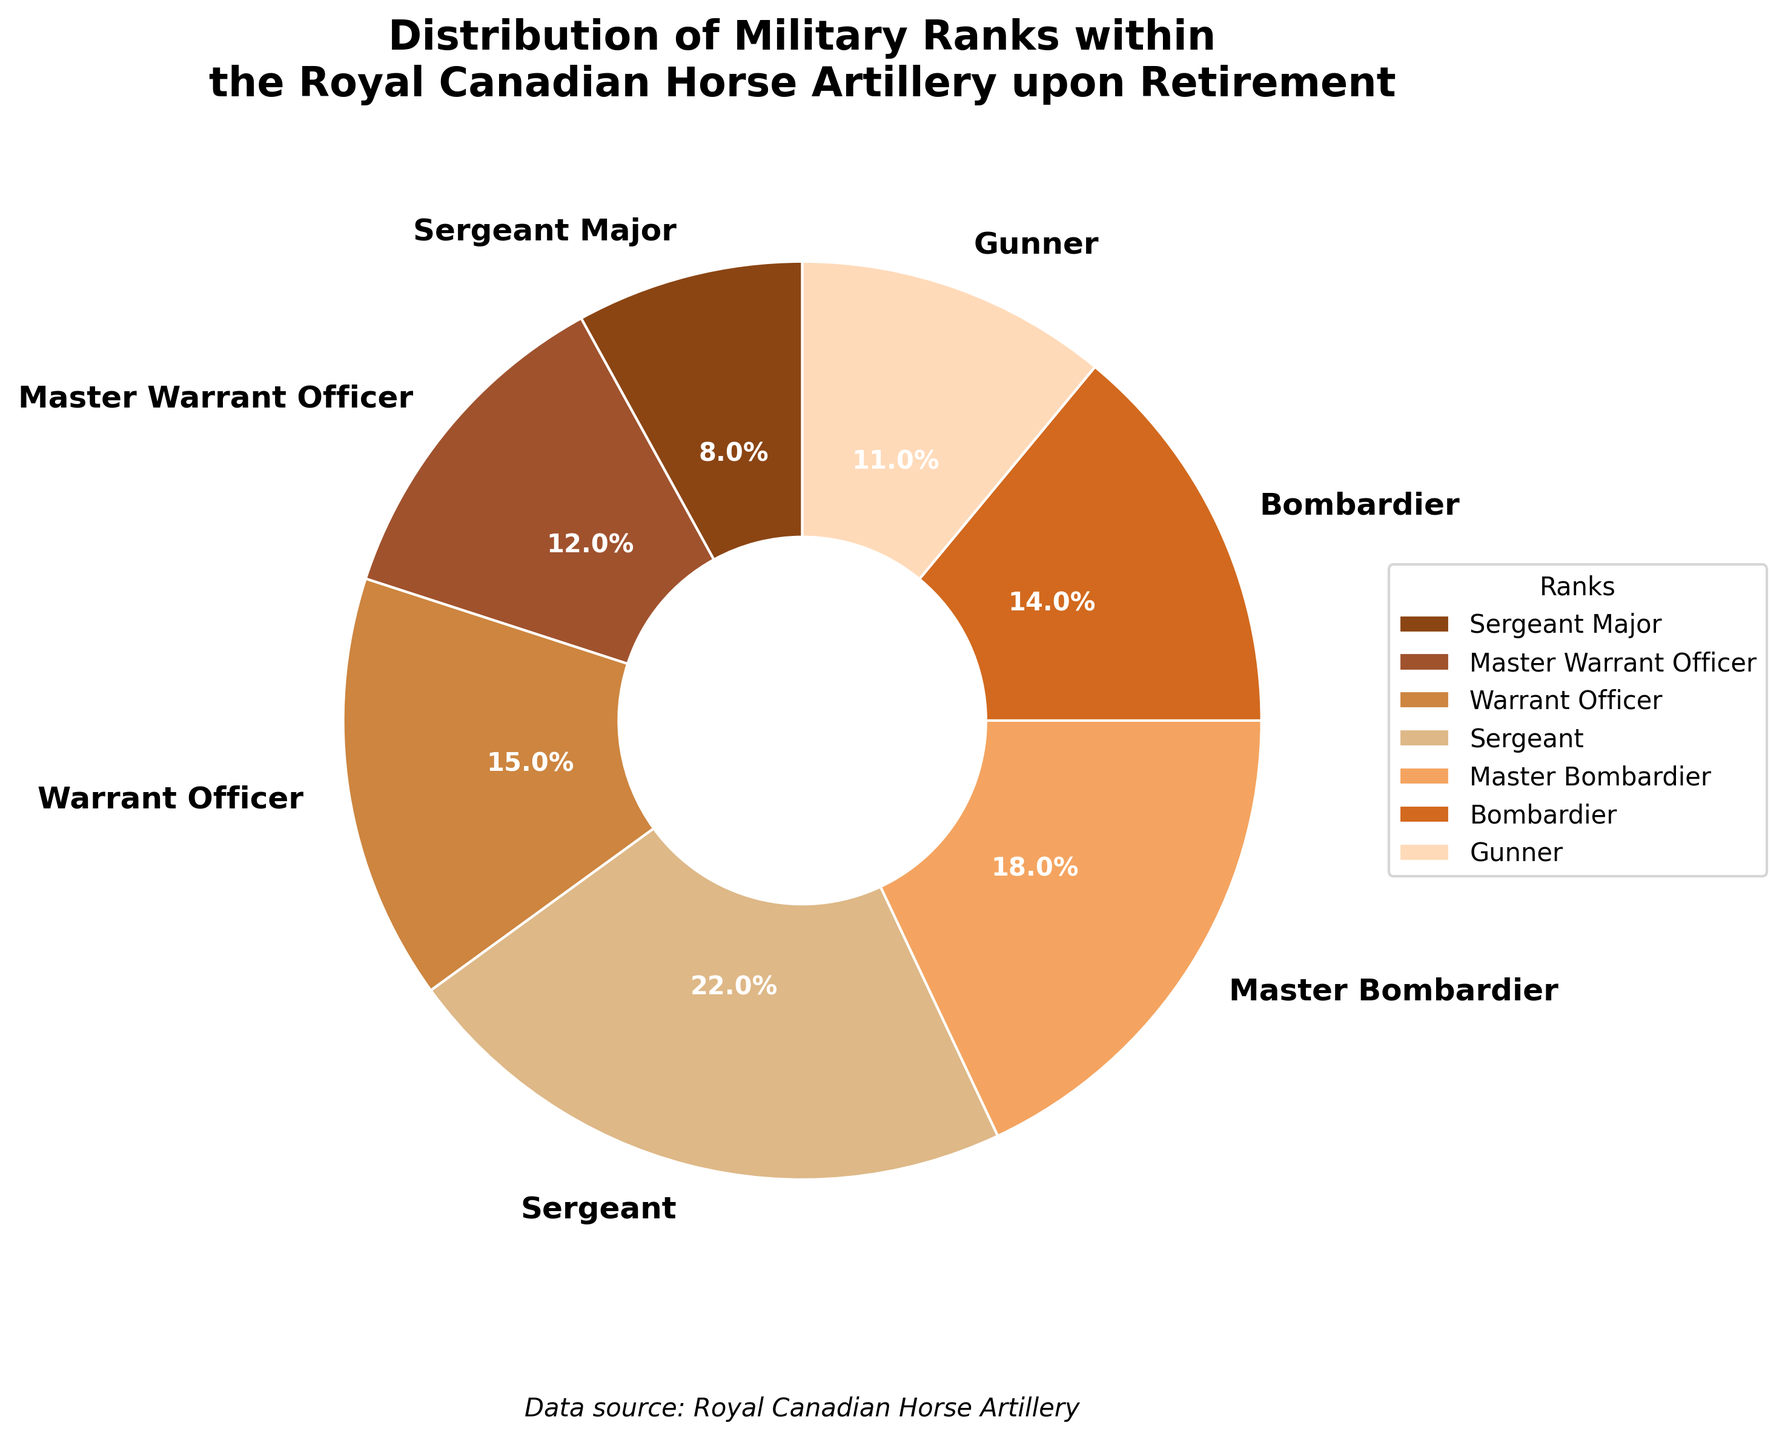Who holds the smallest percentage among the ranks? The percentage values for each rank are displayed on the pie chart. The rank with the smallest percentage is Sergeant Major with 8%.
Answer: Sergeant Major What is the combined percentage of the Bombardier and Master Bombardier ranks? According to the pie chart, Bombardier is 14% and Master Bombardier is 18%. Adding these two percentages together yields 14% + 18% = 32%.
Answer: 32% Which rank has a larger percentage, Warrant Officer or Sergeant Major? The pie chart shows that Warrant Officer has 15% and Sergeant Major has 8%. Since 15% is larger than 8%, Warrant Officer has a larger percentage.
Answer: Warrant Officer What is the median value of the percentages across all ranks? First, list the percentages in ascending order: 8%, 11%, 12%, 14%, 15%, 18%, 22%. Since there are seven values, the median is the fourth value in this ordered list: 14%.
Answer: 14% Are there more Gunners or Sergeants upon retirement? The pie chart shows that Gunners make up 11% and Sergeants make up 22%. Since 22% is greater than 11%, there are more Sergeants.
Answer: Sergeants How much greater is the percentage of Sergeants compared to Gunners? The percentage of Sergeants is 22% and the percentage of Gunners is 11%. The difference between them is 22% - 11% = 11%.
Answer: 11% Which ranks combine to make up exactly half of the total retirees (50%)? By examining the pie chart, we need to find a combination that equals 50%. The values of 22% (Sergeant) and 18% (Master Bombardier) give 40%, and adding 11% (Gunner) gives a total of 51%. So, Bombardier (14%) and Master Bombardier (18%) combine to 32%. Adding any lower percentage won't work. Therefore, nearly half.
Answer: Bombardier and Master Bombardier + any other rank What colors represent the Sergeant Major and Gunner ranks? Refer to the chart's colors to identify the ranks. Sergeant Major is represented by a light brown color, and Gunner is represented by a peach color.
Answer: Light brown for Sergeant Major, peach for Gunner What is the sum of the percentages for ranks with more than 10% representation? Identify which ranks have more than 10%. These include Master Warrant Officer (12%), Warrant Officer (15%), Sergeant (22%), Master Bombardier (18%), and Bombardier (14%). Adding these percentages together: 12% + 15% + 22% + 18% + 14% = 81%.
Answer: 81% 